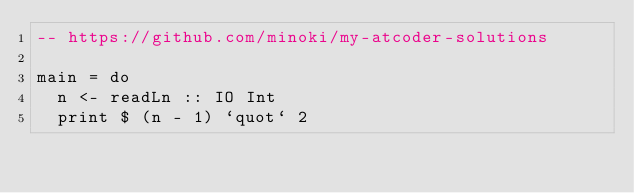<code> <loc_0><loc_0><loc_500><loc_500><_Haskell_>-- https://github.com/minoki/my-atcoder-solutions

main = do
  n <- readLn :: IO Int
  print $ (n - 1) `quot` 2
</code> 